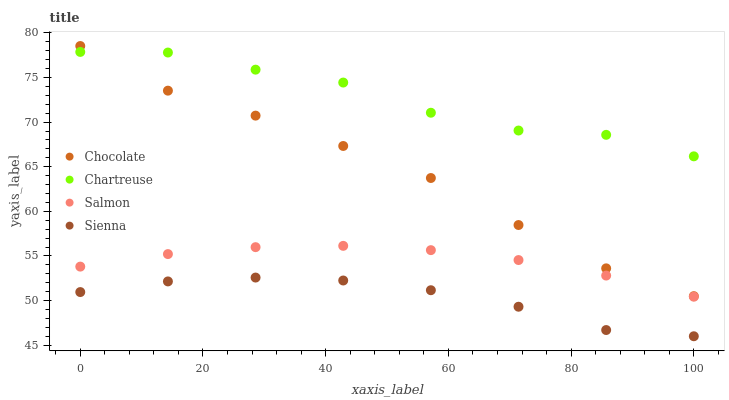Does Sienna have the minimum area under the curve?
Answer yes or no. Yes. Does Chartreuse have the maximum area under the curve?
Answer yes or no. Yes. Does Salmon have the minimum area under the curve?
Answer yes or no. No. Does Salmon have the maximum area under the curve?
Answer yes or no. No. Is Salmon the smoothest?
Answer yes or no. Yes. Is Chartreuse the roughest?
Answer yes or no. Yes. Is Chartreuse the smoothest?
Answer yes or no. No. Is Salmon the roughest?
Answer yes or no. No. Does Sienna have the lowest value?
Answer yes or no. Yes. Does Salmon have the lowest value?
Answer yes or no. No. Does Chocolate have the highest value?
Answer yes or no. Yes. Does Chartreuse have the highest value?
Answer yes or no. No. Is Salmon less than Chartreuse?
Answer yes or no. Yes. Is Chocolate greater than Sienna?
Answer yes or no. Yes. Does Chocolate intersect Chartreuse?
Answer yes or no. Yes. Is Chocolate less than Chartreuse?
Answer yes or no. No. Is Chocolate greater than Chartreuse?
Answer yes or no. No. Does Salmon intersect Chartreuse?
Answer yes or no. No. 